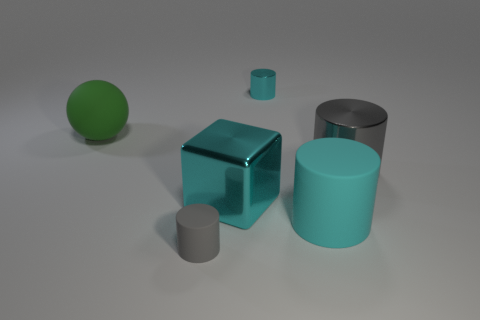Subtract all small matte cylinders. How many cylinders are left? 3 Subtract all cyan cylinders. How many cylinders are left? 2 Add 4 big objects. How many objects exist? 10 Subtract all spheres. How many objects are left? 5 Subtract 2 cylinders. How many cylinders are left? 2 Subtract all cyan balls. Subtract all purple blocks. How many balls are left? 1 Subtract all purple cubes. How many cyan cylinders are left? 2 Subtract all gray things. Subtract all gray rubber cylinders. How many objects are left? 3 Add 5 large green objects. How many large green objects are left? 6 Add 2 cylinders. How many cylinders exist? 6 